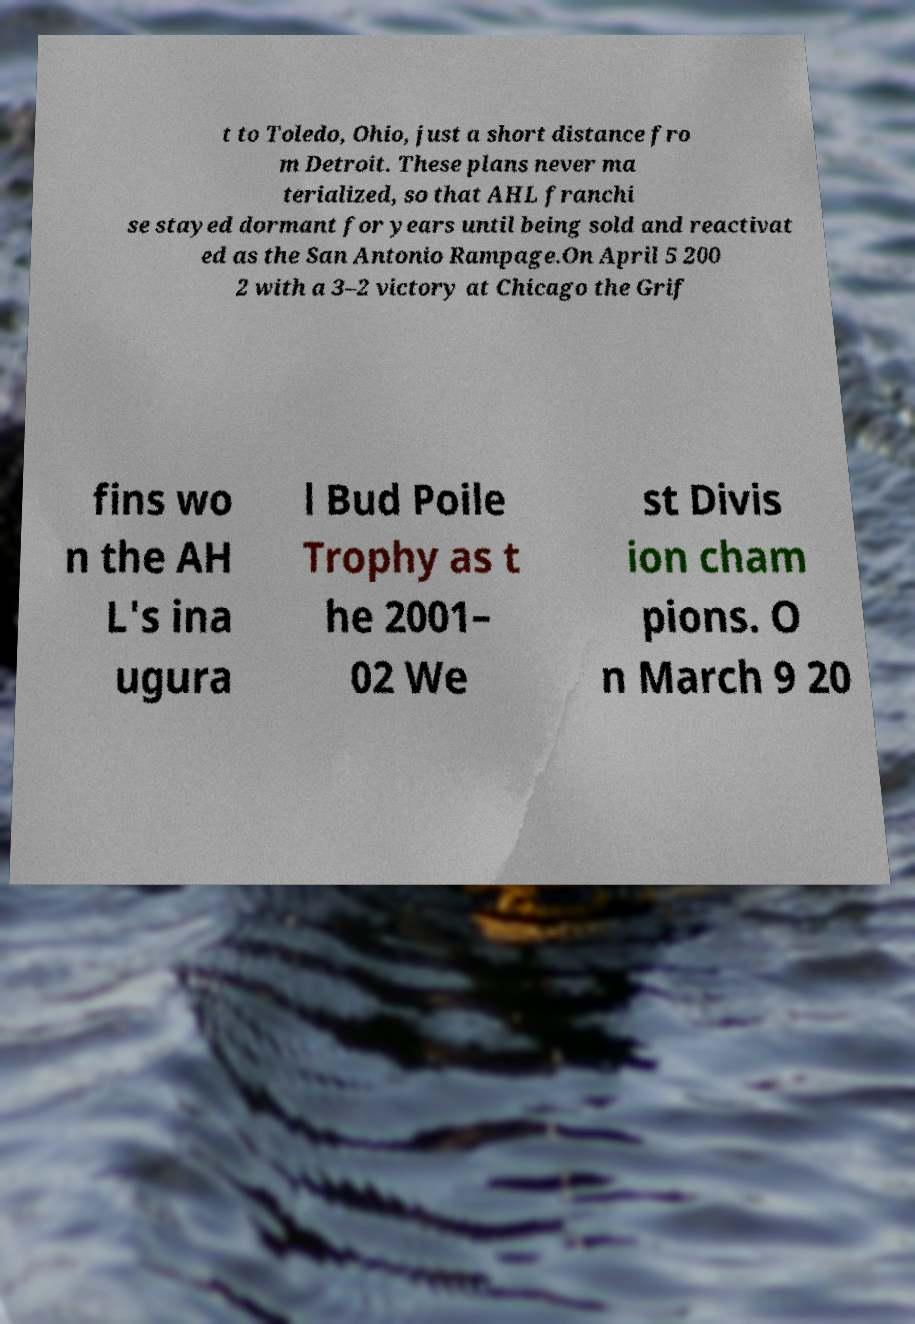Could you extract and type out the text from this image? t to Toledo, Ohio, just a short distance fro m Detroit. These plans never ma terialized, so that AHL franchi se stayed dormant for years until being sold and reactivat ed as the San Antonio Rampage.On April 5 200 2 with a 3–2 victory at Chicago the Grif fins wo n the AH L's ina ugura l Bud Poile Trophy as t he 2001– 02 We st Divis ion cham pions. O n March 9 20 